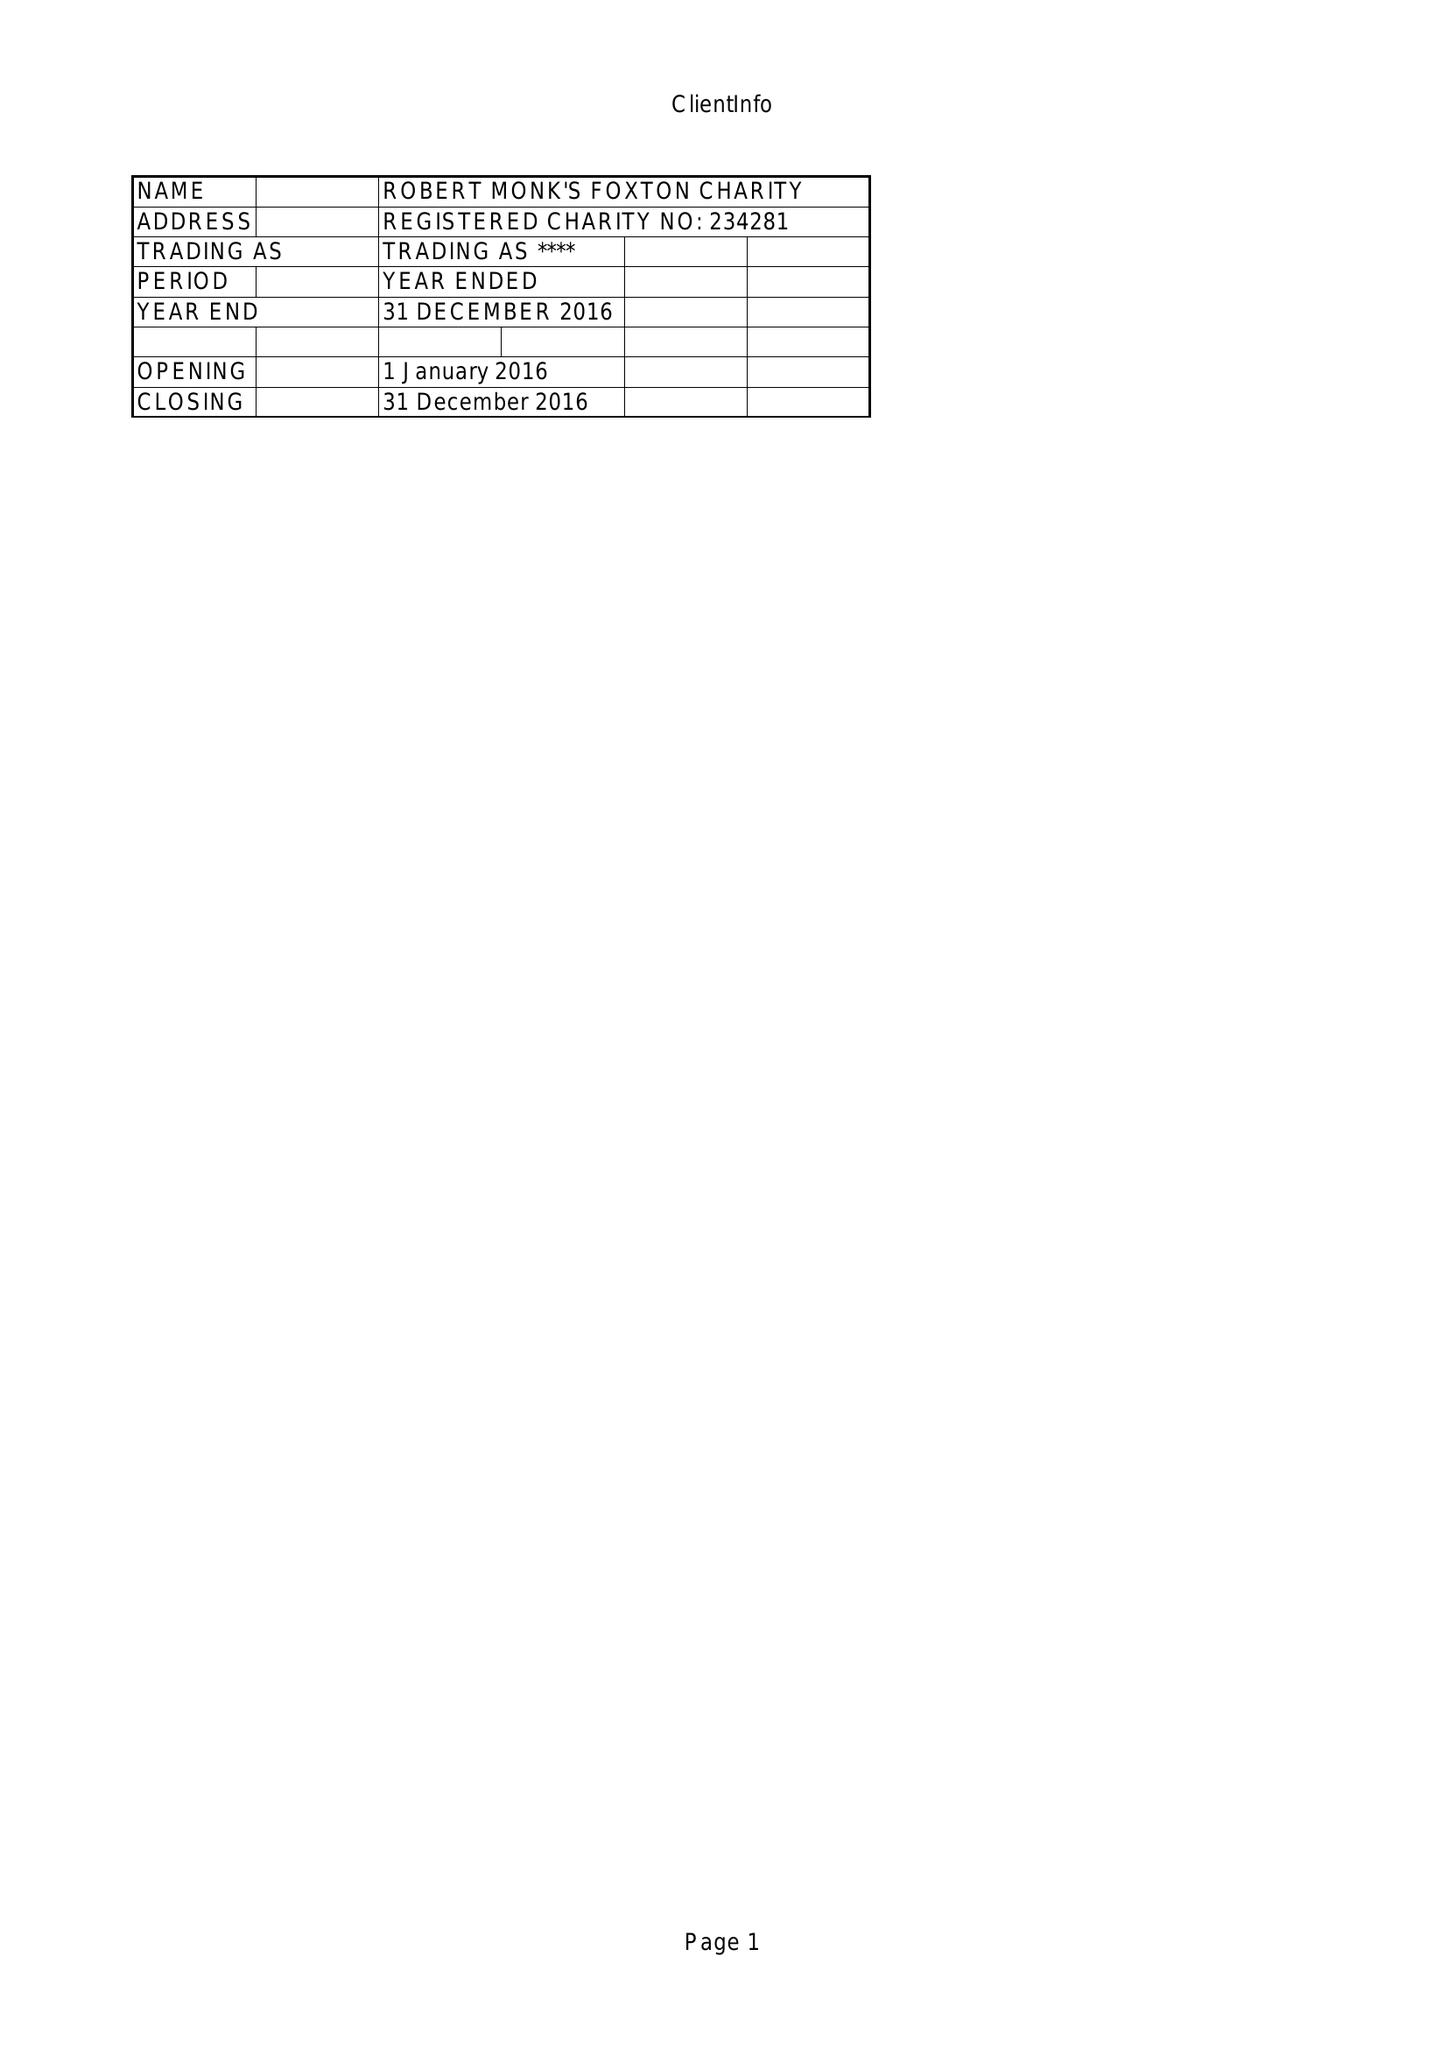What is the value for the address__post_town?
Answer the question using a single word or phrase. MARKET HARBOROUGH 